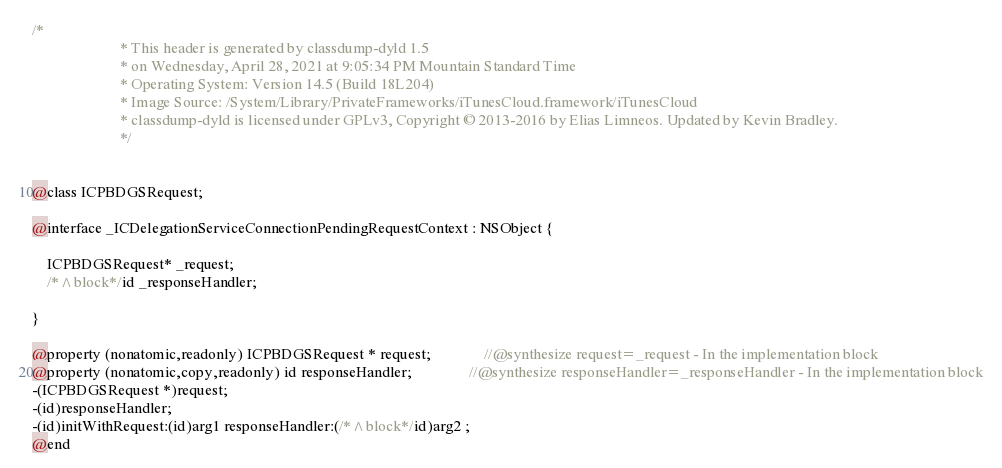<code> <loc_0><loc_0><loc_500><loc_500><_C_>/*
                       * This header is generated by classdump-dyld 1.5
                       * on Wednesday, April 28, 2021 at 9:05:34 PM Mountain Standard Time
                       * Operating System: Version 14.5 (Build 18L204)
                       * Image Source: /System/Library/PrivateFrameworks/iTunesCloud.framework/iTunesCloud
                       * classdump-dyld is licensed under GPLv3, Copyright © 2013-2016 by Elias Limneos. Updated by Kevin Bradley.
                       */


@class ICPBDGSRequest;

@interface _ICDelegationServiceConnectionPendingRequestContext : NSObject {

	ICPBDGSRequest* _request;
	/*^block*/id _responseHandler;

}

@property (nonatomic,readonly) ICPBDGSRequest * request;              //@synthesize request=_request - In the implementation block
@property (nonatomic,copy,readonly) id responseHandler;               //@synthesize responseHandler=_responseHandler - In the implementation block
-(ICPBDGSRequest *)request;
-(id)responseHandler;
-(id)initWithRequest:(id)arg1 responseHandler:(/*^block*/id)arg2 ;
@end

</code> 